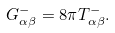Convert formula to latex. <formula><loc_0><loc_0><loc_500><loc_500>G _ { \alpha \beta } ^ { - } = 8 \pi T _ { \alpha \beta } ^ { - } .</formula> 